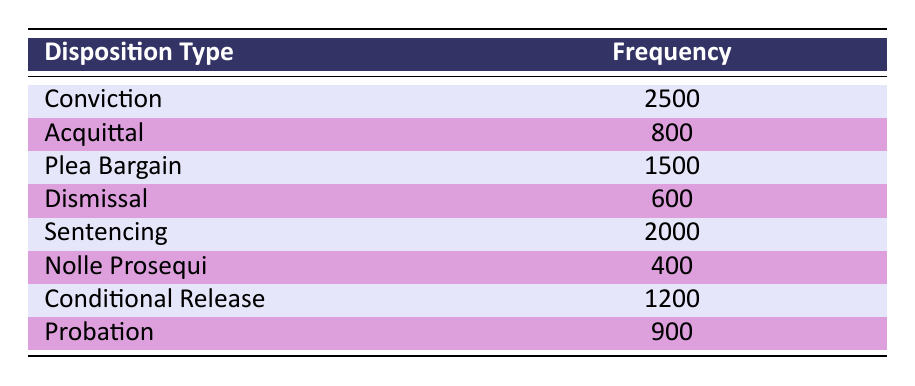What is the frequency of convictions? The table shows that the frequency of convictions is 2500. This value is directly listed under the Disposition Type "Conviction".
Answer: 2500 How many cases were resolved through plea bargains? The table indicates that 1500 cases were resolved through plea bargains, listed directly under the Disposition Type "Plea Bargain".
Answer: 1500 What is the total frequency of dismissals and nolle prosequi cases? To find the total frequency, we add the frequency of dismissals (600) and nolle prosequi cases (400). Therefore, 600 + 400 equals 1000.
Answer: 1000 Which disposition type has the lowest frequency? The lowest frequency in the table is 400, which corresponds to "Nolle Prosequi", identified by comparing all the frequencies listed.
Answer: Nolle Prosequi Is the number of convictions greater than the total number of plea bargains and acquittals combined? First, we find the total number of plea bargains (1500) and acquittals (800). Their sum is 1500 + 800 = 2300. Since 2500 (convictions) is indeed greater than 2300, the answer is yes.
Answer: Yes What is the average frequency of conditional release and probation cases? The frequency of conditional release is 1200 and probation is 900. To find the average, we sum these two frequencies (1200 + 900 = 2100) and then divide by the number of cases (2). Thus, 2100/2 equals 1050.
Answer: 1050 How many cases were resolved through sentencing compared to dismissals? The frequency of sentencing is 2000 and the frequency of dismissals is 600. To compare them, we can note that 2000 is significantly higher than 600, thus indicating that more cases were resolved through sentencing.
Answer: Sentencing is higher How many total criminal cases can be inferred from the table? We can infer the total by adding all the individual frequencies: 2500 (Conviction) + 800 (Acquittal) + 1500 (Plea Bargain) + 600 (Dismissal) + 2000 (Sentencing) + 400 (Nolle Prosequi) + 1200 (Conditional Release) + 900 (Probation) = 11000.
Answer: 11000 Is the frequency of probation cases more than double the frequency of nolle prosequi cases? The frequency of probation is 900 and nolle prosequi cases is 400. Doubling the frequency of nolle prosequi gives us 800. Since 900 is greater than 800, the answer is yes.
Answer: Yes 